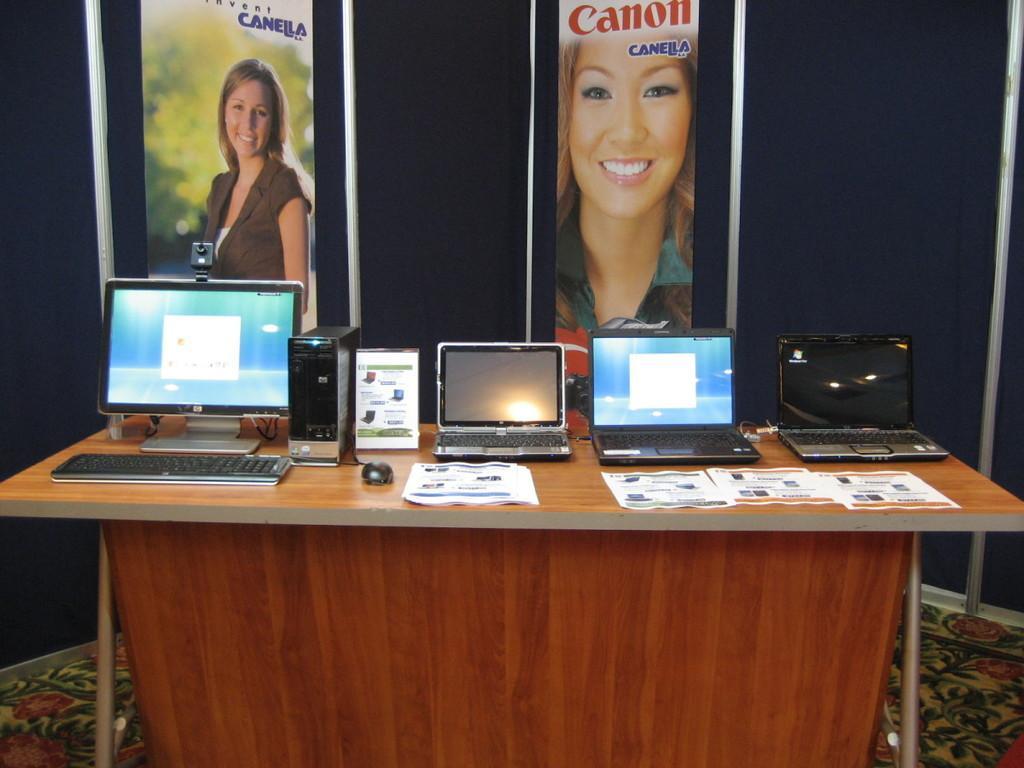In one or two sentences, can you explain what this image depicts? There is wall on which two frames are placed in that there are two women. In front there is a table on which there three laptops and a personal computer is placed, and papers are also placed on the table. There is a floor with a floor mat. 